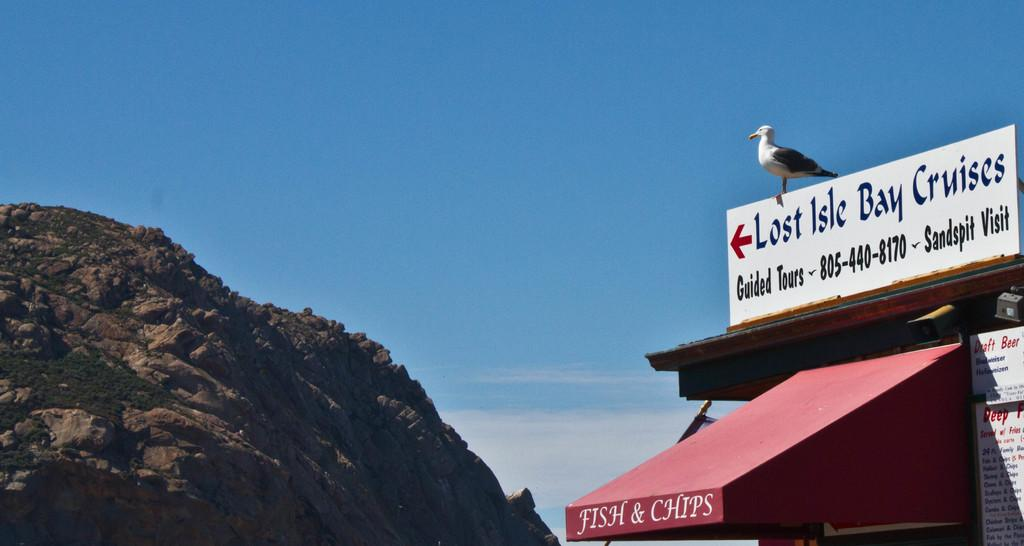<image>
Describe the image concisely. a locale for fish and chips with a sign on the top that says lost isle bay cruises. 